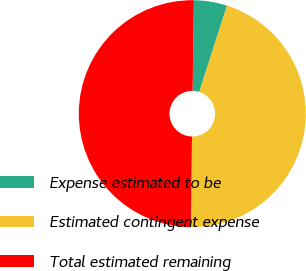<chart> <loc_0><loc_0><loc_500><loc_500><pie_chart><fcel>Expense estimated to be<fcel>Estimated contingent expense<fcel>Total estimated remaining<nl><fcel>4.73%<fcel>45.27%<fcel>50.0%<nl></chart> 